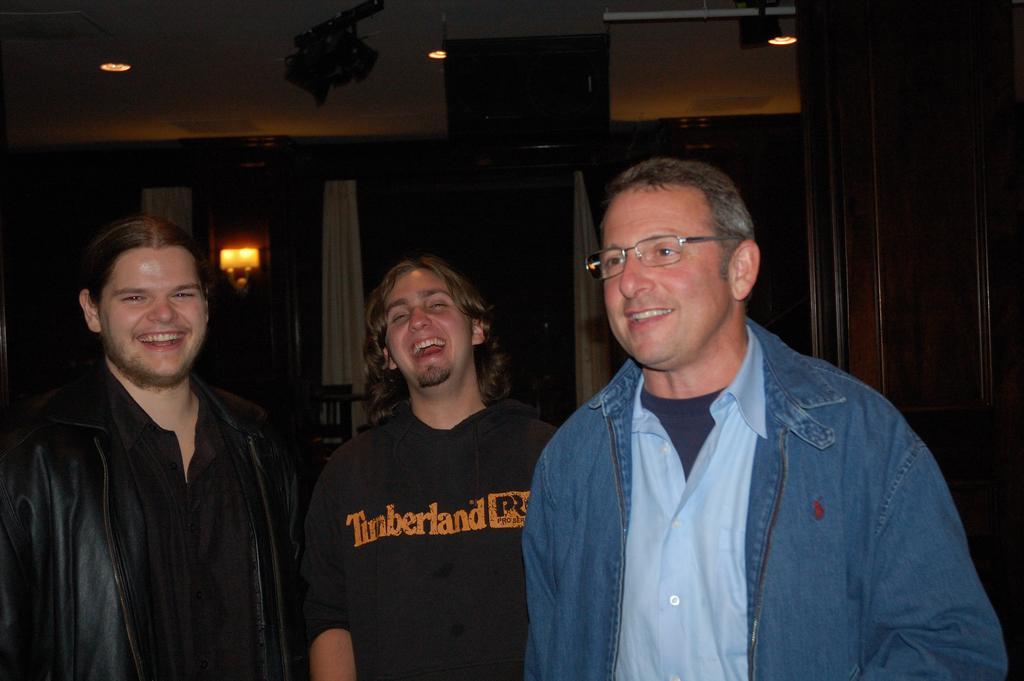Can you describe this image briefly? In the given image i can see a people,lights,curtains and some other objects. 